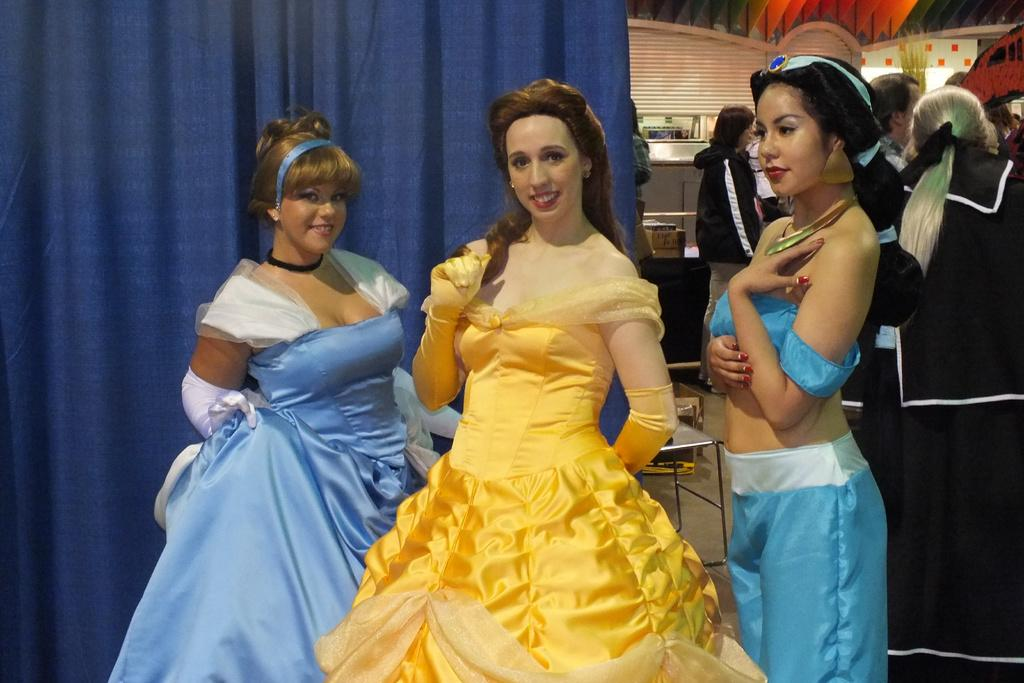How many girls are present in the image? There are three girls in the image. Where are the girls located in the image? The girls are standing on a stage. What are the girls wearing in the image? The girls are wearing gowns. What can be seen at the back of the stage? There is a curtain at the back of the stage. Are there any other people visible in the image? Yes, there is another group of people standing in the image. Can you find the receipt for the gowns the girls are wearing in the image? There is no receipt visible in the image, and we cannot determine the origin of the gowns based on the information provided. 